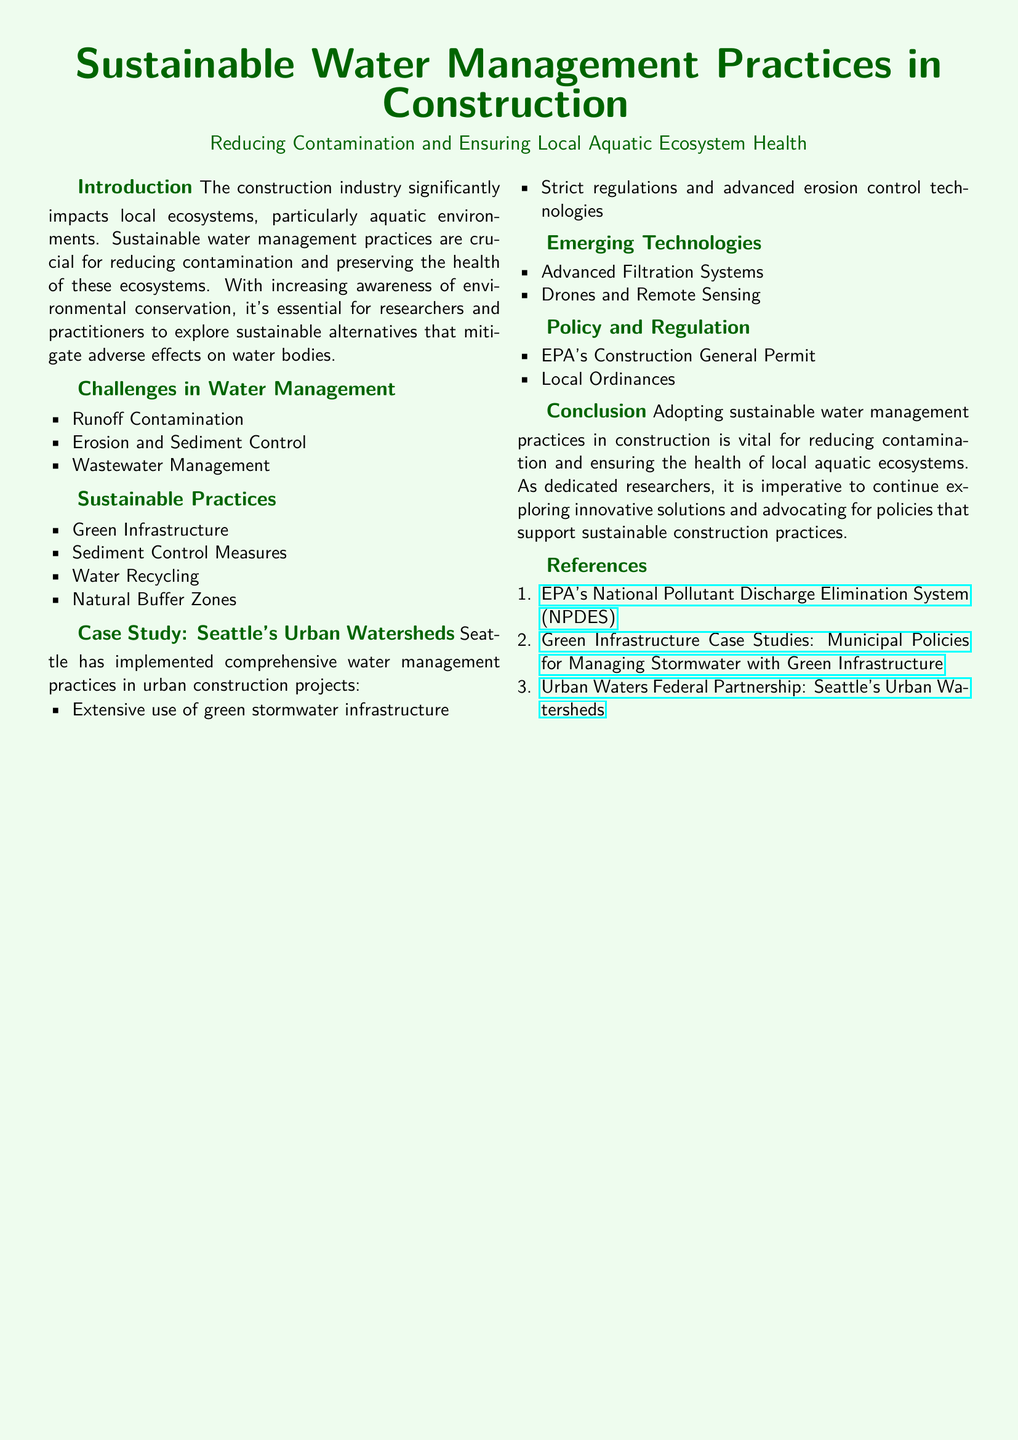What are the three main challenges in water management? The document lists Runoff Contamination, Erosion and Sediment Control, and Wastewater Management as the main challenges.
Answer: Runoff Contamination, Erosion and Sediment Control, Wastewater Management What sustainable practice involves using natural systems for water management? The document mentions Green Infrastructure as a sustainable practice that uses natural systems.
Answer: Green Infrastructure Which city is highlighted in the case study? Seattle is identified as the focus city in the case study section.
Answer: Seattle What advanced technology is mentioned for water management? The document references Advanced Filtration Systems and Drones and Remote Sensing as emerging technologies for water management.
Answer: Advanced Filtration Systems, Drones and Remote Sensing What is the purpose of the EPA's Construction General Permit? The EPA's Construction General Permit aims to regulate discharges from construction activities to protect water quality.
Answer: To regulate discharges from construction activities How many sustainable practices are listed in the document? There are four sustainable practices detailed in the document.
Answer: Four What type of infrastructure has Seattle extensively utilized in its urban watersheds? Extensive use of green stormwater infrastructure is noted as a practice in Seattle's urban watersheds.
Answer: Green stormwater infrastructure What is the overall goal of adopting sustainable water management practices? The ultimate goal mentioned is to reduce contamination and ensure the health of local aquatic ecosystems.
Answer: Reduce contamination and ensure the health of local aquatic ecosystems What is a key consideration for researchers and practitioners noted in the introduction? The introduction emphasizes the importance of exploring sustainable alternatives to mitigate adverse effects on water bodies.
Answer: Exploring sustainable alternatives 